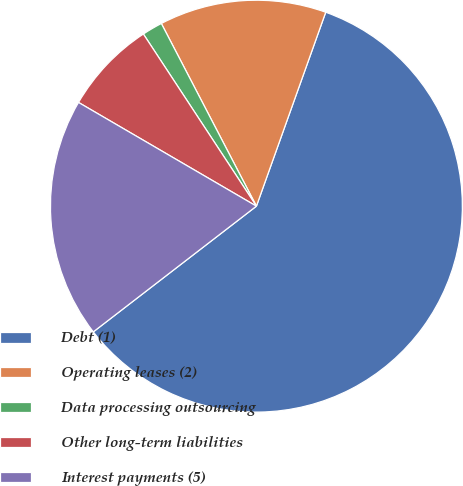Convert chart. <chart><loc_0><loc_0><loc_500><loc_500><pie_chart><fcel>Debt (1)<fcel>Operating leases (2)<fcel>Data processing outsourcing<fcel>Other long-term liabilities<fcel>Interest payments (5)<nl><fcel>59.08%<fcel>13.1%<fcel>1.61%<fcel>7.35%<fcel>18.85%<nl></chart> 